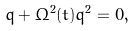<formula> <loc_0><loc_0><loc_500><loc_500>\ddot { q } + \Omega ^ { 2 } ( t ) q ^ { 2 } = 0 ,</formula> 